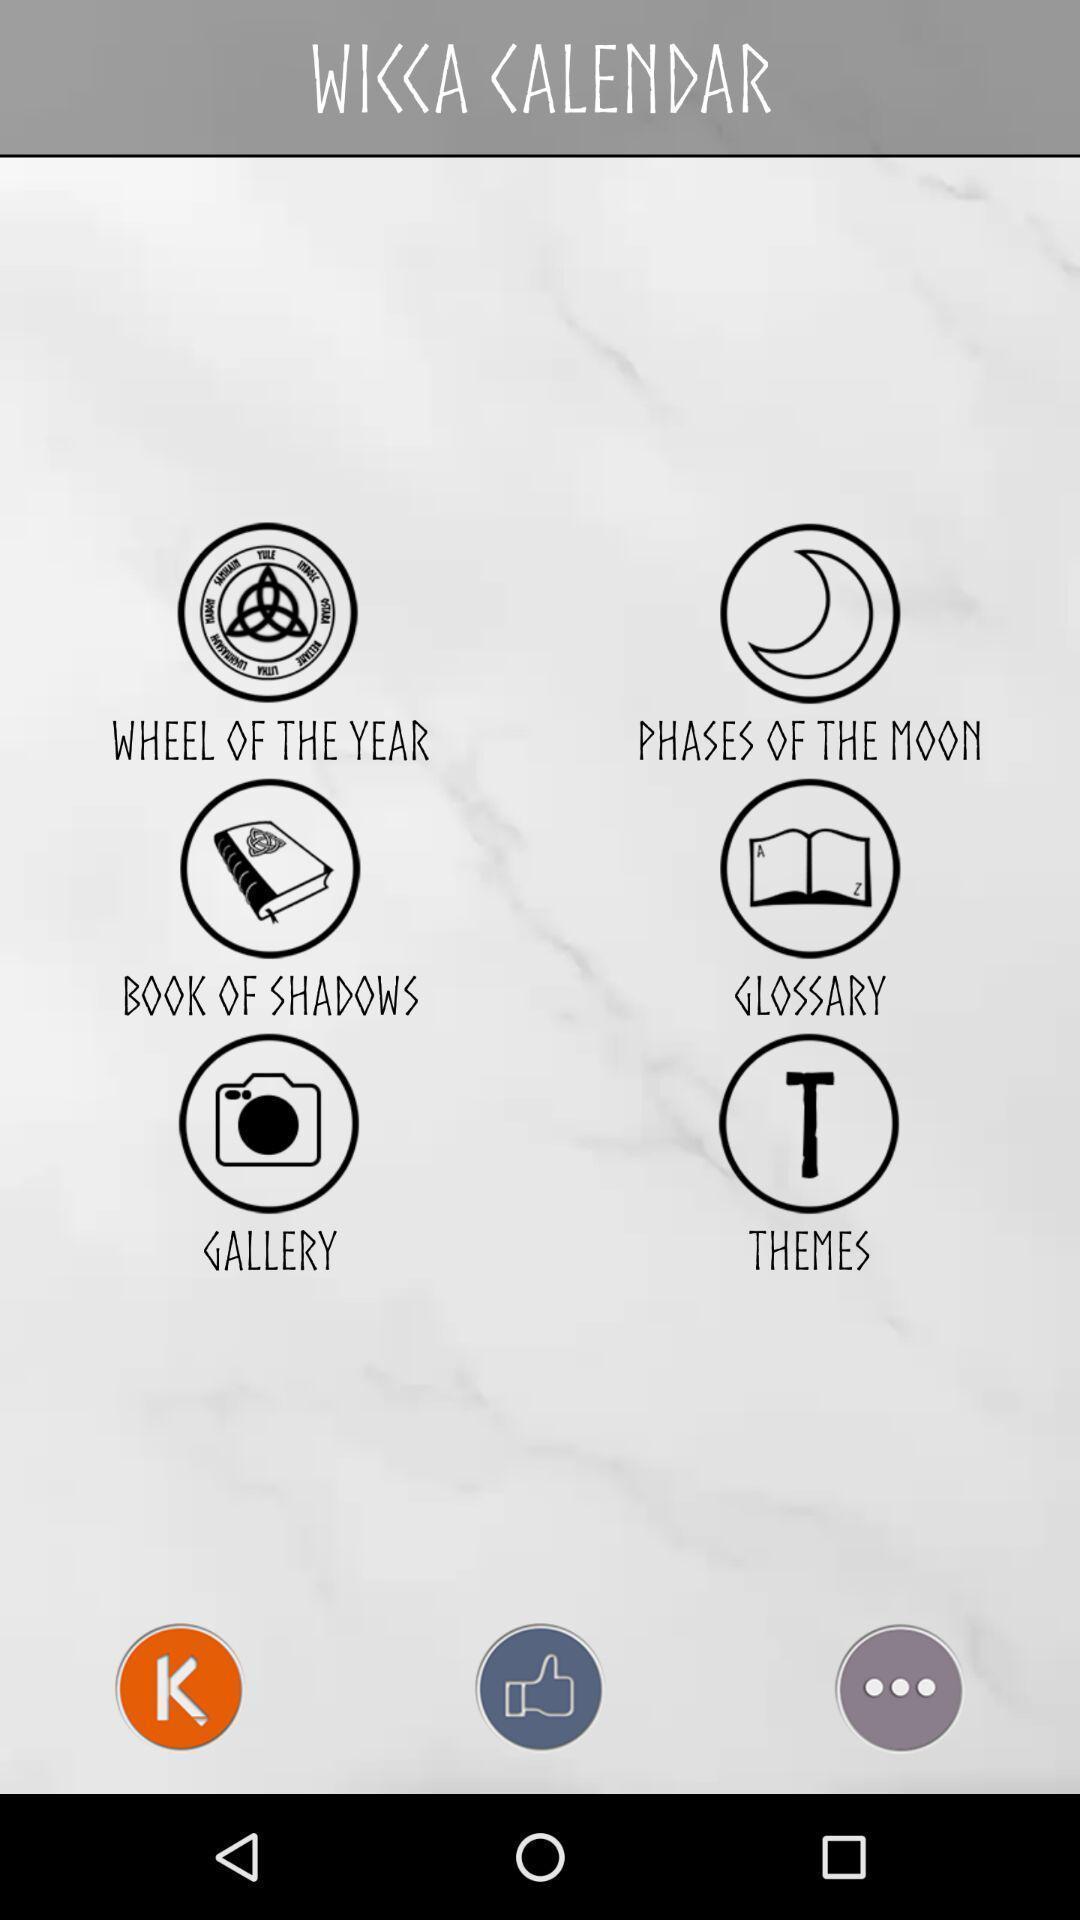What can you discern from this picture? Page showing the multiple options. 